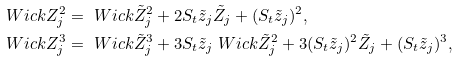<formula> <loc_0><loc_0><loc_500><loc_500>\ W i c k { Z _ { j } ^ { 2 } } & = \ W i c k { \tilde { Z } _ { j } ^ { 2 } } + 2 S _ { t } \tilde { z } _ { j } \tilde { Z } _ { j } + ( S _ { t } \tilde { z } _ { j } ) ^ { 2 } , \\ \ W i c k { Z _ { j } ^ { 3 } } & = \ W i c k { \tilde { Z } _ { j } ^ { 3 } } + 3 S _ { t } \tilde { z } _ { j } \ W i c k { \tilde { Z } _ { j } ^ { 2 } } + 3 ( S _ { t } \tilde { z } _ { j } ) ^ { 2 } \tilde { Z } _ { j } + ( S _ { t } \tilde { z } _ { j } ) ^ { 3 } ,</formula> 